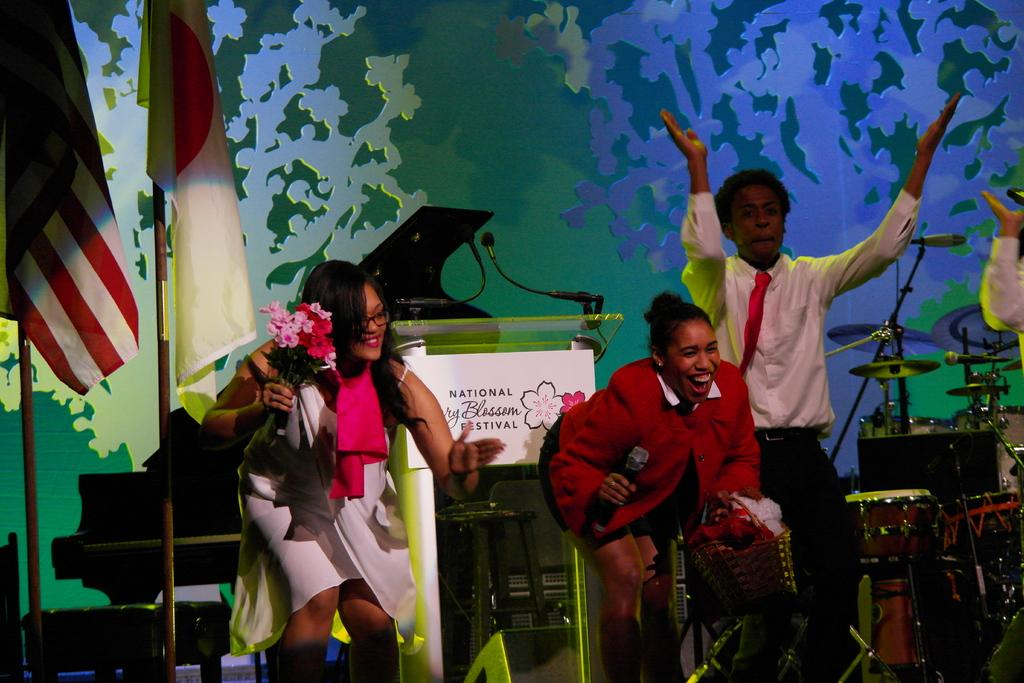What is happening in the image involving the three people? The three people are performing in the image. What is the surface they are performing on? They are performing on a daisy. Are there any other objects or symbols present in the image? Yes, there are two flags on poles in the image. Can you see a toad hopping near the daisy in the image? No, there is no toad present in the image. What type of office furniture can be seen in the image? There is no office furniture present in the image. 